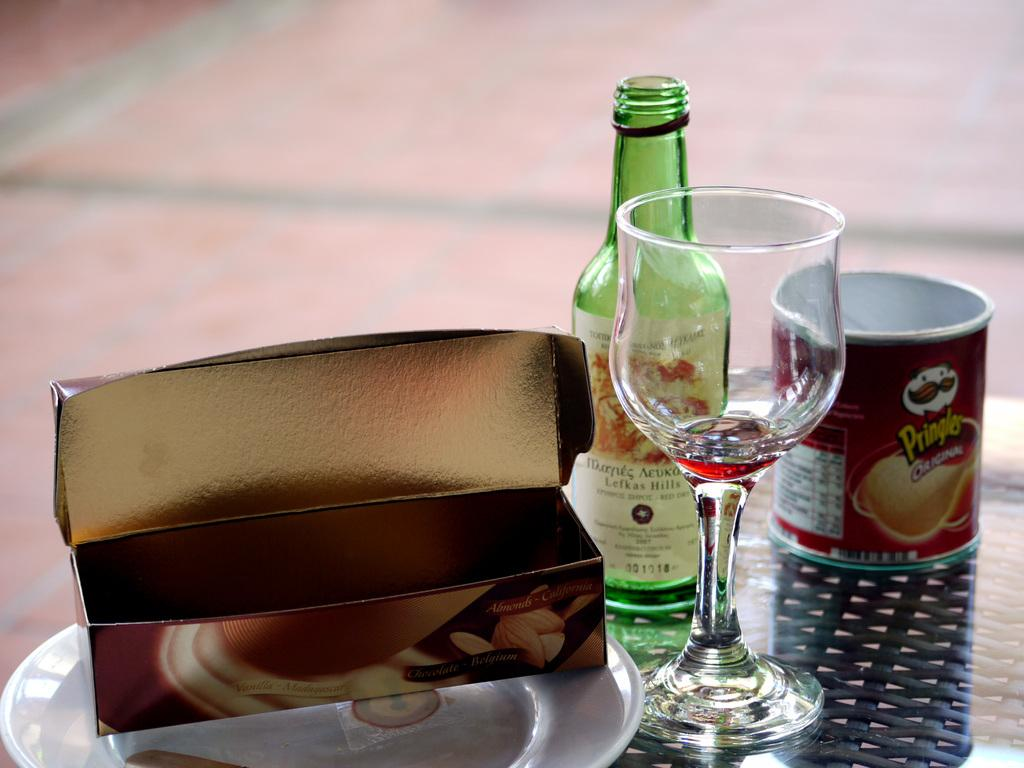What object is placed on a plate in the image? There is a box on a plate in the image. What type of container is visible in the image? There is a glass and a cup in the image. What is the color of the bottle in the image? There is a green-colored bottle in the image. Can you tell me how many snakes are wrapped around the green-colored bottle in the image? There are no snakes present in the image; it only features a box on a plate, a glass, a cup, and a green-colored bottle. 